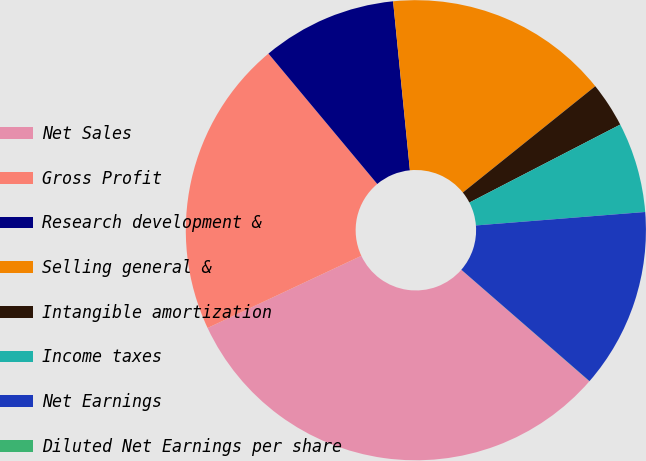Convert chart to OTSL. <chart><loc_0><loc_0><loc_500><loc_500><pie_chart><fcel>Net Sales<fcel>Gross Profit<fcel>Research development &<fcel>Selling general &<fcel>Intangible amortization<fcel>Income taxes<fcel>Net Earnings<fcel>Diluted Net Earnings per share<nl><fcel>31.61%<fcel>20.91%<fcel>9.49%<fcel>15.81%<fcel>3.17%<fcel>6.33%<fcel>12.65%<fcel>0.01%<nl></chart> 